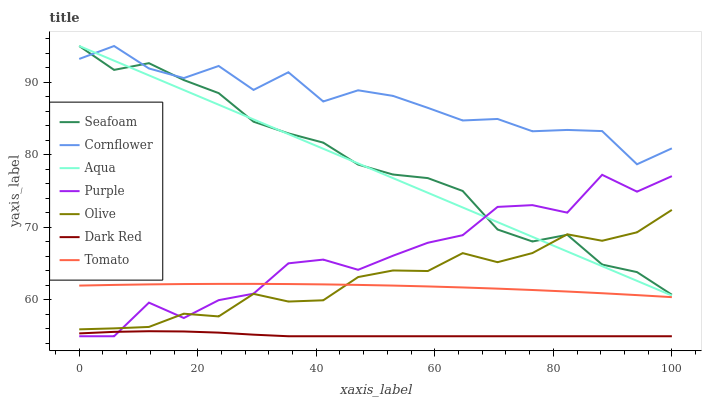Does Purple have the minimum area under the curve?
Answer yes or no. No. Does Purple have the maximum area under the curve?
Answer yes or no. No. Is Cornflower the smoothest?
Answer yes or no. No. Is Cornflower the roughest?
Answer yes or no. No. Does Cornflower have the lowest value?
Answer yes or no. No. Does Purple have the highest value?
Answer yes or no. No. Is Dark Red less than Tomato?
Answer yes or no. Yes. Is Seafoam greater than Dark Red?
Answer yes or no. Yes. Does Dark Red intersect Tomato?
Answer yes or no. No. 